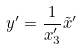Convert formula to latex. <formula><loc_0><loc_0><loc_500><loc_500>y ^ { \prime } = \frac { 1 } { x _ { 3 } ^ { \prime } } \tilde { x } ^ { \prime }</formula> 